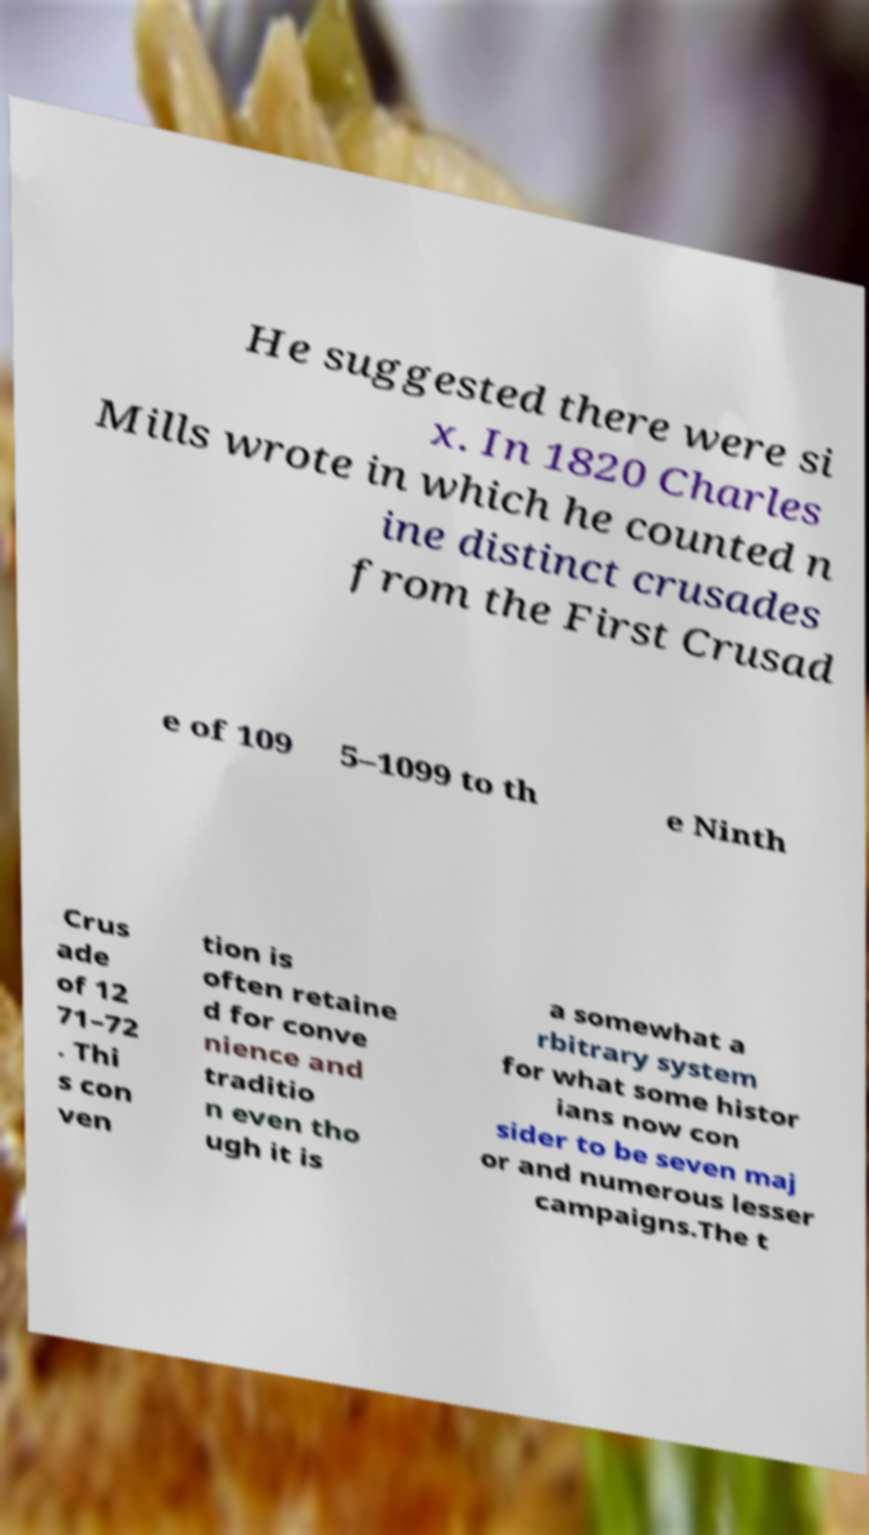There's text embedded in this image that I need extracted. Can you transcribe it verbatim? He suggested there were si x. In 1820 Charles Mills wrote in which he counted n ine distinct crusades from the First Crusad e of 109 5–1099 to th e Ninth Crus ade of 12 71–72 . Thi s con ven tion is often retaine d for conve nience and traditio n even tho ugh it is a somewhat a rbitrary system for what some histor ians now con sider to be seven maj or and numerous lesser campaigns.The t 